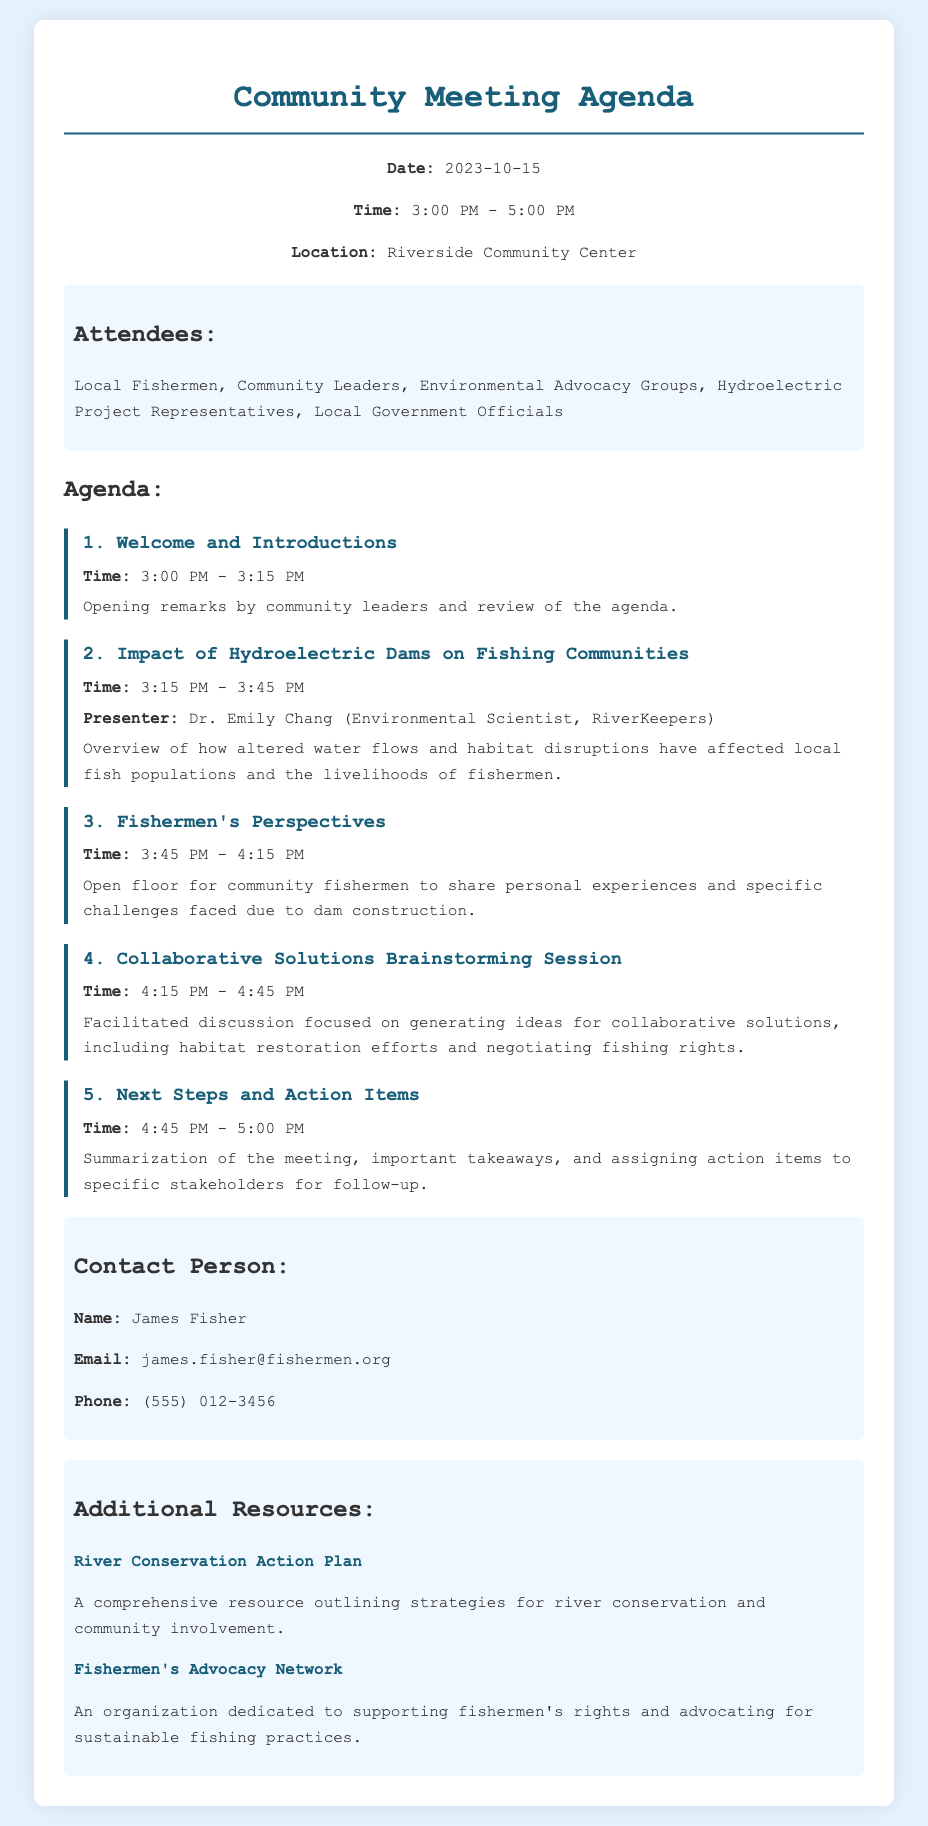What is the date of the meeting? The date is specifically mentioned in the header info section of the document.
Answer: 2023-10-15 What time does the meeting start? The starting time is indicated in the header info section of the document.
Answer: 3:00 PM Who is presenting on the impact of hydroelectric dams? The document clearly states the presenter's name under the agenda item for that topic.
Answer: Dr. Emily Chang What is the focus of the brainstorming session? The agenda describes the topic of the session, indicating its purpose.
Answer: Collaborative solutions How long is the session for fishermen's perspectives? The duration of each agenda item is included in the document.
Answer: 30 minutes Which organization is dedicated to supporting fishermen's rights? This information can be found in the additional resources section.
Answer: Fishermen's Advocacy Network What is the phone number of the contact person? The contact information section provides this detail.
Answer: (555) 012-3456 What location will the meeting take place? The location is outlined in the header info section of the document.
Answer: Riverside Community Center What is the total number of agenda items? By counting the distinct items listed in the agenda, the total can be determined.
Answer: 5 